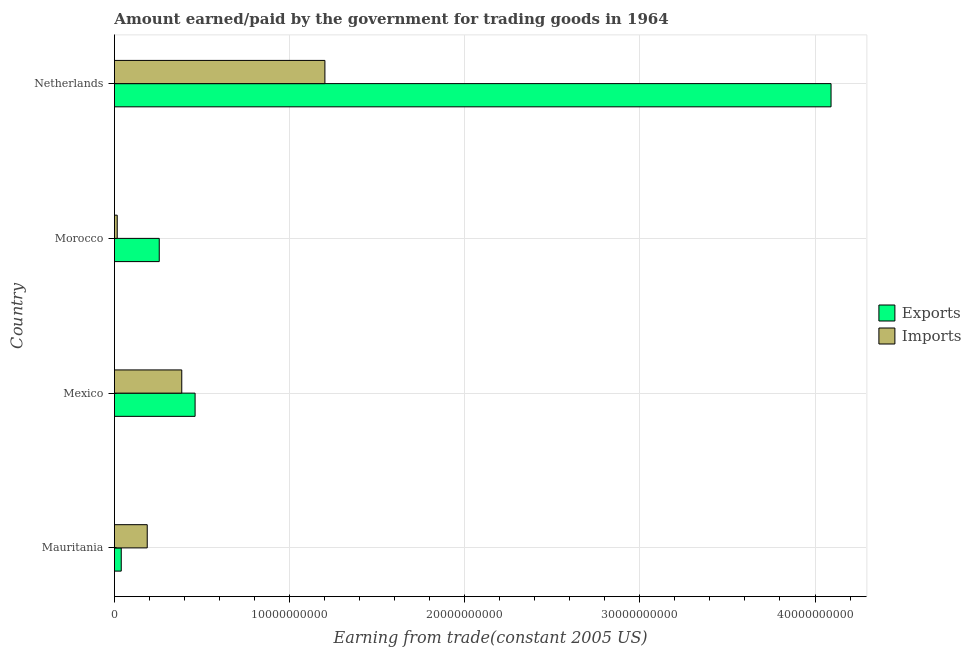Are the number of bars on each tick of the Y-axis equal?
Make the answer very short. Yes. How many bars are there on the 2nd tick from the top?
Provide a short and direct response. 2. What is the label of the 2nd group of bars from the top?
Your answer should be compact. Morocco. In how many cases, is the number of bars for a given country not equal to the number of legend labels?
Keep it short and to the point. 0. What is the amount earned from exports in Netherlands?
Give a very brief answer. 4.09e+1. Across all countries, what is the maximum amount paid for imports?
Ensure brevity in your answer.  1.20e+1. Across all countries, what is the minimum amount earned from exports?
Your answer should be compact. 3.89e+08. In which country was the amount paid for imports minimum?
Ensure brevity in your answer.  Morocco. What is the total amount earned from exports in the graph?
Offer a very short reply. 4.85e+1. What is the difference between the amount paid for imports in Morocco and that in Netherlands?
Your answer should be compact. -1.19e+1. What is the difference between the amount paid for imports in Mexico and the amount earned from exports in Morocco?
Your response must be concise. 1.29e+09. What is the average amount earned from exports per country?
Your answer should be compact. 1.21e+1. What is the difference between the amount paid for imports and amount earned from exports in Netherlands?
Your answer should be compact. -2.89e+1. What is the ratio of the amount earned from exports in Mexico to that in Morocco?
Ensure brevity in your answer.  1.8. Is the amount earned from exports in Mauritania less than that in Netherlands?
Your response must be concise. Yes. Is the difference between the amount earned from exports in Mauritania and Mexico greater than the difference between the amount paid for imports in Mauritania and Mexico?
Give a very brief answer. No. What is the difference between the highest and the second highest amount earned from exports?
Provide a succinct answer. 3.63e+1. What is the difference between the highest and the lowest amount earned from exports?
Keep it short and to the point. 4.05e+1. In how many countries, is the amount earned from exports greater than the average amount earned from exports taken over all countries?
Offer a terse response. 1. Is the sum of the amount earned from exports in Mexico and Morocco greater than the maximum amount paid for imports across all countries?
Provide a succinct answer. No. What does the 1st bar from the top in Mauritania represents?
Ensure brevity in your answer.  Imports. What does the 1st bar from the bottom in Mexico represents?
Provide a short and direct response. Exports. How many bars are there?
Ensure brevity in your answer.  8. How many countries are there in the graph?
Offer a very short reply. 4. Are the values on the major ticks of X-axis written in scientific E-notation?
Give a very brief answer. No. Does the graph contain any zero values?
Make the answer very short. No. Does the graph contain grids?
Your response must be concise. Yes. How many legend labels are there?
Offer a terse response. 2. What is the title of the graph?
Provide a short and direct response. Amount earned/paid by the government for trading goods in 1964. Does "Food and tobacco" appear as one of the legend labels in the graph?
Provide a succinct answer. No. What is the label or title of the X-axis?
Your answer should be compact. Earning from trade(constant 2005 US). What is the label or title of the Y-axis?
Your response must be concise. Country. What is the Earning from trade(constant 2005 US) of Exports in Mauritania?
Offer a terse response. 3.89e+08. What is the Earning from trade(constant 2005 US) of Imports in Mauritania?
Offer a very short reply. 1.87e+09. What is the Earning from trade(constant 2005 US) in Exports in Mexico?
Keep it short and to the point. 4.61e+09. What is the Earning from trade(constant 2005 US) of Imports in Mexico?
Provide a succinct answer. 3.84e+09. What is the Earning from trade(constant 2005 US) in Exports in Morocco?
Keep it short and to the point. 2.56e+09. What is the Earning from trade(constant 2005 US) of Imports in Morocco?
Ensure brevity in your answer.  1.60e+08. What is the Earning from trade(constant 2005 US) of Exports in Netherlands?
Your response must be concise. 4.09e+1. What is the Earning from trade(constant 2005 US) in Imports in Netherlands?
Offer a terse response. 1.20e+1. Across all countries, what is the maximum Earning from trade(constant 2005 US) of Exports?
Your response must be concise. 4.09e+1. Across all countries, what is the maximum Earning from trade(constant 2005 US) of Imports?
Your answer should be compact. 1.20e+1. Across all countries, what is the minimum Earning from trade(constant 2005 US) in Exports?
Your answer should be compact. 3.89e+08. Across all countries, what is the minimum Earning from trade(constant 2005 US) of Imports?
Give a very brief answer. 1.60e+08. What is the total Earning from trade(constant 2005 US) in Exports in the graph?
Your answer should be compact. 4.85e+1. What is the total Earning from trade(constant 2005 US) of Imports in the graph?
Offer a very short reply. 1.79e+1. What is the difference between the Earning from trade(constant 2005 US) in Exports in Mauritania and that in Mexico?
Make the answer very short. -4.22e+09. What is the difference between the Earning from trade(constant 2005 US) of Imports in Mauritania and that in Mexico?
Your answer should be very brief. -1.97e+09. What is the difference between the Earning from trade(constant 2005 US) in Exports in Mauritania and that in Morocco?
Provide a succinct answer. -2.17e+09. What is the difference between the Earning from trade(constant 2005 US) in Imports in Mauritania and that in Morocco?
Give a very brief answer. 1.71e+09. What is the difference between the Earning from trade(constant 2005 US) in Exports in Mauritania and that in Netherlands?
Give a very brief answer. -4.05e+1. What is the difference between the Earning from trade(constant 2005 US) of Imports in Mauritania and that in Netherlands?
Make the answer very short. -1.01e+1. What is the difference between the Earning from trade(constant 2005 US) of Exports in Mexico and that in Morocco?
Provide a succinct answer. 2.05e+09. What is the difference between the Earning from trade(constant 2005 US) of Imports in Mexico and that in Morocco?
Provide a succinct answer. 3.68e+09. What is the difference between the Earning from trade(constant 2005 US) of Exports in Mexico and that in Netherlands?
Offer a terse response. -3.63e+1. What is the difference between the Earning from trade(constant 2005 US) of Imports in Mexico and that in Netherlands?
Your answer should be very brief. -8.17e+09. What is the difference between the Earning from trade(constant 2005 US) in Exports in Morocco and that in Netherlands?
Offer a terse response. -3.84e+1. What is the difference between the Earning from trade(constant 2005 US) of Imports in Morocco and that in Netherlands?
Your response must be concise. -1.19e+1. What is the difference between the Earning from trade(constant 2005 US) in Exports in Mauritania and the Earning from trade(constant 2005 US) in Imports in Mexico?
Your response must be concise. -3.46e+09. What is the difference between the Earning from trade(constant 2005 US) of Exports in Mauritania and the Earning from trade(constant 2005 US) of Imports in Morocco?
Offer a terse response. 2.29e+08. What is the difference between the Earning from trade(constant 2005 US) in Exports in Mauritania and the Earning from trade(constant 2005 US) in Imports in Netherlands?
Your answer should be compact. -1.16e+1. What is the difference between the Earning from trade(constant 2005 US) of Exports in Mexico and the Earning from trade(constant 2005 US) of Imports in Morocco?
Give a very brief answer. 4.45e+09. What is the difference between the Earning from trade(constant 2005 US) in Exports in Mexico and the Earning from trade(constant 2005 US) in Imports in Netherlands?
Provide a succinct answer. -7.41e+09. What is the difference between the Earning from trade(constant 2005 US) of Exports in Morocco and the Earning from trade(constant 2005 US) of Imports in Netherlands?
Provide a short and direct response. -9.46e+09. What is the average Earning from trade(constant 2005 US) of Exports per country?
Your answer should be very brief. 1.21e+1. What is the average Earning from trade(constant 2005 US) of Imports per country?
Provide a short and direct response. 4.47e+09. What is the difference between the Earning from trade(constant 2005 US) in Exports and Earning from trade(constant 2005 US) in Imports in Mauritania?
Make the answer very short. -1.48e+09. What is the difference between the Earning from trade(constant 2005 US) of Exports and Earning from trade(constant 2005 US) of Imports in Mexico?
Ensure brevity in your answer.  7.61e+08. What is the difference between the Earning from trade(constant 2005 US) in Exports and Earning from trade(constant 2005 US) in Imports in Morocco?
Your response must be concise. 2.40e+09. What is the difference between the Earning from trade(constant 2005 US) in Exports and Earning from trade(constant 2005 US) in Imports in Netherlands?
Make the answer very short. 2.89e+1. What is the ratio of the Earning from trade(constant 2005 US) of Exports in Mauritania to that in Mexico?
Your response must be concise. 0.08. What is the ratio of the Earning from trade(constant 2005 US) in Imports in Mauritania to that in Mexico?
Provide a succinct answer. 0.49. What is the ratio of the Earning from trade(constant 2005 US) of Exports in Mauritania to that in Morocco?
Give a very brief answer. 0.15. What is the ratio of the Earning from trade(constant 2005 US) of Imports in Mauritania to that in Morocco?
Offer a terse response. 11.71. What is the ratio of the Earning from trade(constant 2005 US) in Exports in Mauritania to that in Netherlands?
Provide a short and direct response. 0.01. What is the ratio of the Earning from trade(constant 2005 US) of Imports in Mauritania to that in Netherlands?
Your answer should be very brief. 0.16. What is the ratio of the Earning from trade(constant 2005 US) in Exports in Mexico to that in Morocco?
Offer a terse response. 1.8. What is the ratio of the Earning from trade(constant 2005 US) of Imports in Mexico to that in Morocco?
Provide a succinct answer. 24.04. What is the ratio of the Earning from trade(constant 2005 US) in Exports in Mexico to that in Netherlands?
Offer a terse response. 0.11. What is the ratio of the Earning from trade(constant 2005 US) in Imports in Mexico to that in Netherlands?
Offer a very short reply. 0.32. What is the ratio of the Earning from trade(constant 2005 US) in Exports in Morocco to that in Netherlands?
Keep it short and to the point. 0.06. What is the ratio of the Earning from trade(constant 2005 US) of Imports in Morocco to that in Netherlands?
Your response must be concise. 0.01. What is the difference between the highest and the second highest Earning from trade(constant 2005 US) in Exports?
Your answer should be compact. 3.63e+1. What is the difference between the highest and the second highest Earning from trade(constant 2005 US) in Imports?
Provide a short and direct response. 8.17e+09. What is the difference between the highest and the lowest Earning from trade(constant 2005 US) of Exports?
Make the answer very short. 4.05e+1. What is the difference between the highest and the lowest Earning from trade(constant 2005 US) in Imports?
Give a very brief answer. 1.19e+1. 